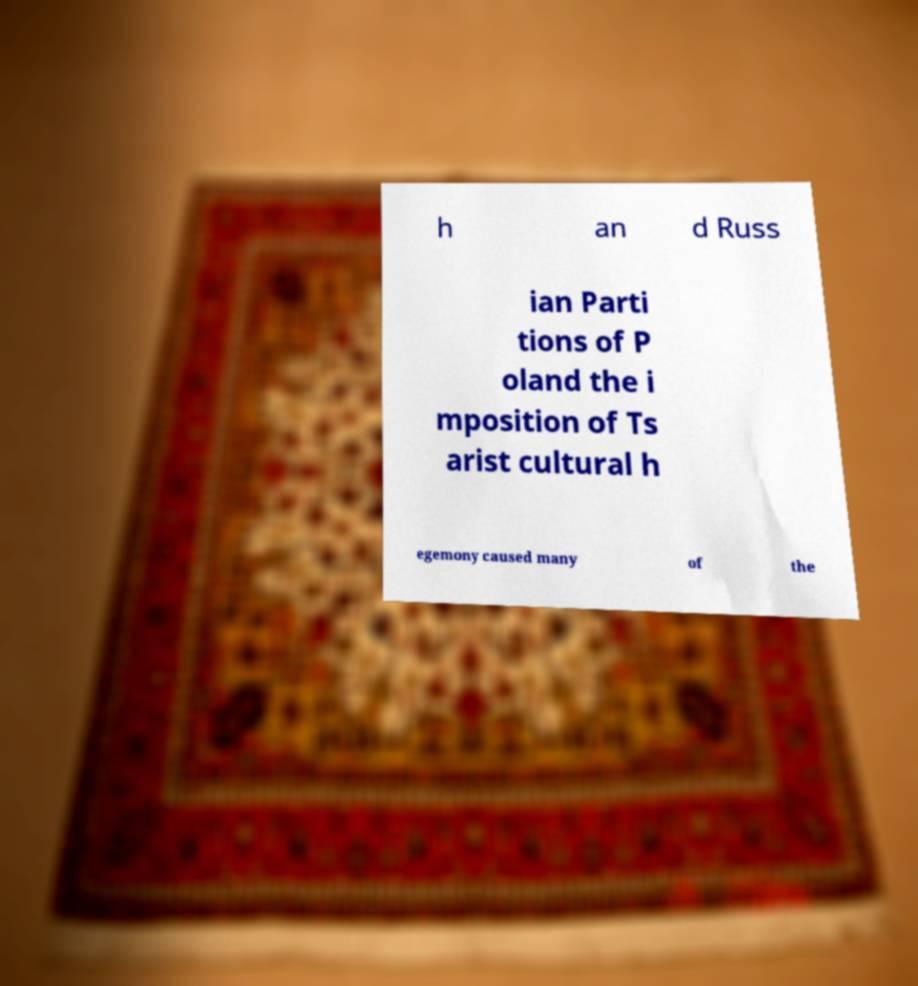Please identify and transcribe the text found in this image. h an d Russ ian Parti tions of P oland the i mposition of Ts arist cultural h egemony caused many of the 